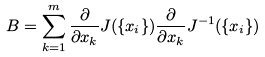<formula> <loc_0><loc_0><loc_500><loc_500>B = \sum _ { k = 1 } ^ { m } \frac { \partial } { \partial x _ { k } } J ( \{ x _ { i } \} ) \frac { \partial } { \partial x _ { k } } J ^ { - 1 } ( \{ x _ { i } \} )</formula> 